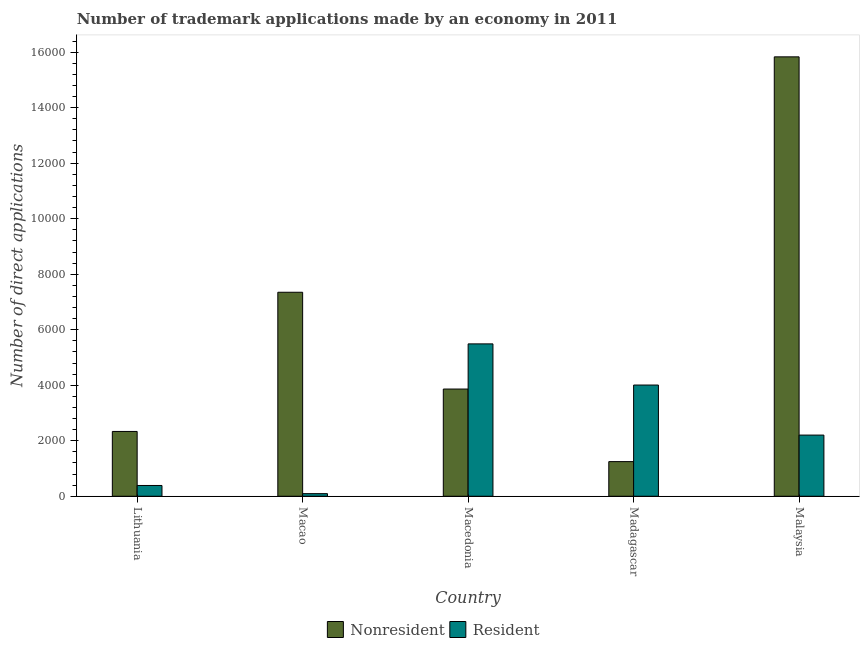How many different coloured bars are there?
Your response must be concise. 2. How many groups of bars are there?
Provide a short and direct response. 5. Are the number of bars on each tick of the X-axis equal?
Offer a terse response. Yes. How many bars are there on the 4th tick from the left?
Keep it short and to the point. 2. How many bars are there on the 2nd tick from the right?
Make the answer very short. 2. What is the label of the 3rd group of bars from the left?
Ensure brevity in your answer.  Macedonia. In how many cases, is the number of bars for a given country not equal to the number of legend labels?
Offer a terse response. 0. What is the number of trademark applications made by residents in Macedonia?
Make the answer very short. 5490. Across all countries, what is the maximum number of trademark applications made by residents?
Your response must be concise. 5490. Across all countries, what is the minimum number of trademark applications made by non residents?
Your answer should be very brief. 1248. In which country was the number of trademark applications made by residents maximum?
Your response must be concise. Macedonia. In which country was the number of trademark applications made by non residents minimum?
Provide a succinct answer. Madagascar. What is the total number of trademark applications made by residents in the graph?
Give a very brief answer. 1.22e+04. What is the difference between the number of trademark applications made by residents in Macedonia and that in Malaysia?
Provide a succinct answer. 3286. What is the difference between the number of trademark applications made by residents in Malaysia and the number of trademark applications made by non residents in Lithuania?
Offer a terse response. -131. What is the average number of trademark applications made by non residents per country?
Ensure brevity in your answer.  6125.6. What is the difference between the number of trademark applications made by residents and number of trademark applications made by non residents in Malaysia?
Your response must be concise. -1.36e+04. In how many countries, is the number of trademark applications made by residents greater than 8400 ?
Provide a short and direct response. 0. What is the ratio of the number of trademark applications made by non residents in Macedonia to that in Malaysia?
Provide a short and direct response. 0.24. What is the difference between the highest and the second highest number of trademark applications made by residents?
Your answer should be very brief. 1483. What is the difference between the highest and the lowest number of trademark applications made by non residents?
Provide a short and direct response. 1.46e+04. In how many countries, is the number of trademark applications made by residents greater than the average number of trademark applications made by residents taken over all countries?
Offer a very short reply. 2. What does the 2nd bar from the left in Lithuania represents?
Give a very brief answer. Resident. What does the 1st bar from the right in Macao represents?
Provide a succinct answer. Resident. How many bars are there?
Ensure brevity in your answer.  10. Are all the bars in the graph horizontal?
Your answer should be very brief. No. Does the graph contain grids?
Make the answer very short. No. How are the legend labels stacked?
Your answer should be compact. Horizontal. What is the title of the graph?
Offer a terse response. Number of trademark applications made by an economy in 2011. What is the label or title of the Y-axis?
Make the answer very short. Number of direct applications. What is the Number of direct applications of Nonresident in Lithuania?
Offer a very short reply. 2335. What is the Number of direct applications in Resident in Lithuania?
Your answer should be compact. 388. What is the Number of direct applications of Nonresident in Macao?
Offer a very short reply. 7350. What is the Number of direct applications in Resident in Macao?
Your answer should be very brief. 94. What is the Number of direct applications in Nonresident in Macedonia?
Your answer should be very brief. 3863. What is the Number of direct applications in Resident in Macedonia?
Offer a very short reply. 5490. What is the Number of direct applications in Nonresident in Madagascar?
Give a very brief answer. 1248. What is the Number of direct applications of Resident in Madagascar?
Offer a terse response. 4007. What is the Number of direct applications in Nonresident in Malaysia?
Provide a succinct answer. 1.58e+04. What is the Number of direct applications of Resident in Malaysia?
Provide a short and direct response. 2204. Across all countries, what is the maximum Number of direct applications of Nonresident?
Offer a terse response. 1.58e+04. Across all countries, what is the maximum Number of direct applications in Resident?
Your answer should be very brief. 5490. Across all countries, what is the minimum Number of direct applications in Nonresident?
Your answer should be compact. 1248. Across all countries, what is the minimum Number of direct applications in Resident?
Offer a terse response. 94. What is the total Number of direct applications of Nonresident in the graph?
Your answer should be compact. 3.06e+04. What is the total Number of direct applications in Resident in the graph?
Your answer should be very brief. 1.22e+04. What is the difference between the Number of direct applications of Nonresident in Lithuania and that in Macao?
Ensure brevity in your answer.  -5015. What is the difference between the Number of direct applications of Resident in Lithuania and that in Macao?
Provide a succinct answer. 294. What is the difference between the Number of direct applications of Nonresident in Lithuania and that in Macedonia?
Your answer should be very brief. -1528. What is the difference between the Number of direct applications in Resident in Lithuania and that in Macedonia?
Your response must be concise. -5102. What is the difference between the Number of direct applications in Nonresident in Lithuania and that in Madagascar?
Make the answer very short. 1087. What is the difference between the Number of direct applications in Resident in Lithuania and that in Madagascar?
Provide a succinct answer. -3619. What is the difference between the Number of direct applications in Nonresident in Lithuania and that in Malaysia?
Your response must be concise. -1.35e+04. What is the difference between the Number of direct applications of Resident in Lithuania and that in Malaysia?
Provide a short and direct response. -1816. What is the difference between the Number of direct applications in Nonresident in Macao and that in Macedonia?
Provide a succinct answer. 3487. What is the difference between the Number of direct applications of Resident in Macao and that in Macedonia?
Your response must be concise. -5396. What is the difference between the Number of direct applications of Nonresident in Macao and that in Madagascar?
Keep it short and to the point. 6102. What is the difference between the Number of direct applications in Resident in Macao and that in Madagascar?
Give a very brief answer. -3913. What is the difference between the Number of direct applications of Nonresident in Macao and that in Malaysia?
Provide a short and direct response. -8482. What is the difference between the Number of direct applications of Resident in Macao and that in Malaysia?
Provide a short and direct response. -2110. What is the difference between the Number of direct applications of Nonresident in Macedonia and that in Madagascar?
Your answer should be compact. 2615. What is the difference between the Number of direct applications of Resident in Macedonia and that in Madagascar?
Your answer should be very brief. 1483. What is the difference between the Number of direct applications of Nonresident in Macedonia and that in Malaysia?
Make the answer very short. -1.20e+04. What is the difference between the Number of direct applications of Resident in Macedonia and that in Malaysia?
Your response must be concise. 3286. What is the difference between the Number of direct applications in Nonresident in Madagascar and that in Malaysia?
Your answer should be compact. -1.46e+04. What is the difference between the Number of direct applications of Resident in Madagascar and that in Malaysia?
Your answer should be compact. 1803. What is the difference between the Number of direct applications in Nonresident in Lithuania and the Number of direct applications in Resident in Macao?
Provide a succinct answer. 2241. What is the difference between the Number of direct applications of Nonresident in Lithuania and the Number of direct applications of Resident in Macedonia?
Provide a succinct answer. -3155. What is the difference between the Number of direct applications in Nonresident in Lithuania and the Number of direct applications in Resident in Madagascar?
Your answer should be very brief. -1672. What is the difference between the Number of direct applications in Nonresident in Lithuania and the Number of direct applications in Resident in Malaysia?
Offer a terse response. 131. What is the difference between the Number of direct applications in Nonresident in Macao and the Number of direct applications in Resident in Macedonia?
Your answer should be compact. 1860. What is the difference between the Number of direct applications of Nonresident in Macao and the Number of direct applications of Resident in Madagascar?
Ensure brevity in your answer.  3343. What is the difference between the Number of direct applications in Nonresident in Macao and the Number of direct applications in Resident in Malaysia?
Your response must be concise. 5146. What is the difference between the Number of direct applications of Nonresident in Macedonia and the Number of direct applications of Resident in Madagascar?
Your answer should be compact. -144. What is the difference between the Number of direct applications of Nonresident in Macedonia and the Number of direct applications of Resident in Malaysia?
Your answer should be very brief. 1659. What is the difference between the Number of direct applications of Nonresident in Madagascar and the Number of direct applications of Resident in Malaysia?
Your response must be concise. -956. What is the average Number of direct applications of Nonresident per country?
Provide a short and direct response. 6125.6. What is the average Number of direct applications in Resident per country?
Your answer should be compact. 2436.6. What is the difference between the Number of direct applications of Nonresident and Number of direct applications of Resident in Lithuania?
Offer a terse response. 1947. What is the difference between the Number of direct applications of Nonresident and Number of direct applications of Resident in Macao?
Give a very brief answer. 7256. What is the difference between the Number of direct applications in Nonresident and Number of direct applications in Resident in Macedonia?
Provide a succinct answer. -1627. What is the difference between the Number of direct applications in Nonresident and Number of direct applications in Resident in Madagascar?
Keep it short and to the point. -2759. What is the difference between the Number of direct applications of Nonresident and Number of direct applications of Resident in Malaysia?
Provide a succinct answer. 1.36e+04. What is the ratio of the Number of direct applications in Nonresident in Lithuania to that in Macao?
Keep it short and to the point. 0.32. What is the ratio of the Number of direct applications of Resident in Lithuania to that in Macao?
Keep it short and to the point. 4.13. What is the ratio of the Number of direct applications in Nonresident in Lithuania to that in Macedonia?
Provide a succinct answer. 0.6. What is the ratio of the Number of direct applications of Resident in Lithuania to that in Macedonia?
Provide a succinct answer. 0.07. What is the ratio of the Number of direct applications of Nonresident in Lithuania to that in Madagascar?
Your answer should be compact. 1.87. What is the ratio of the Number of direct applications in Resident in Lithuania to that in Madagascar?
Your response must be concise. 0.1. What is the ratio of the Number of direct applications in Nonresident in Lithuania to that in Malaysia?
Ensure brevity in your answer.  0.15. What is the ratio of the Number of direct applications in Resident in Lithuania to that in Malaysia?
Give a very brief answer. 0.18. What is the ratio of the Number of direct applications in Nonresident in Macao to that in Macedonia?
Ensure brevity in your answer.  1.9. What is the ratio of the Number of direct applications of Resident in Macao to that in Macedonia?
Give a very brief answer. 0.02. What is the ratio of the Number of direct applications of Nonresident in Macao to that in Madagascar?
Give a very brief answer. 5.89. What is the ratio of the Number of direct applications in Resident in Macao to that in Madagascar?
Make the answer very short. 0.02. What is the ratio of the Number of direct applications in Nonresident in Macao to that in Malaysia?
Ensure brevity in your answer.  0.46. What is the ratio of the Number of direct applications of Resident in Macao to that in Malaysia?
Give a very brief answer. 0.04. What is the ratio of the Number of direct applications in Nonresident in Macedonia to that in Madagascar?
Your answer should be compact. 3.1. What is the ratio of the Number of direct applications of Resident in Macedonia to that in Madagascar?
Your answer should be compact. 1.37. What is the ratio of the Number of direct applications in Nonresident in Macedonia to that in Malaysia?
Your response must be concise. 0.24. What is the ratio of the Number of direct applications in Resident in Macedonia to that in Malaysia?
Offer a terse response. 2.49. What is the ratio of the Number of direct applications in Nonresident in Madagascar to that in Malaysia?
Make the answer very short. 0.08. What is the ratio of the Number of direct applications in Resident in Madagascar to that in Malaysia?
Make the answer very short. 1.82. What is the difference between the highest and the second highest Number of direct applications of Nonresident?
Provide a succinct answer. 8482. What is the difference between the highest and the second highest Number of direct applications in Resident?
Your answer should be compact. 1483. What is the difference between the highest and the lowest Number of direct applications of Nonresident?
Your answer should be compact. 1.46e+04. What is the difference between the highest and the lowest Number of direct applications in Resident?
Your response must be concise. 5396. 